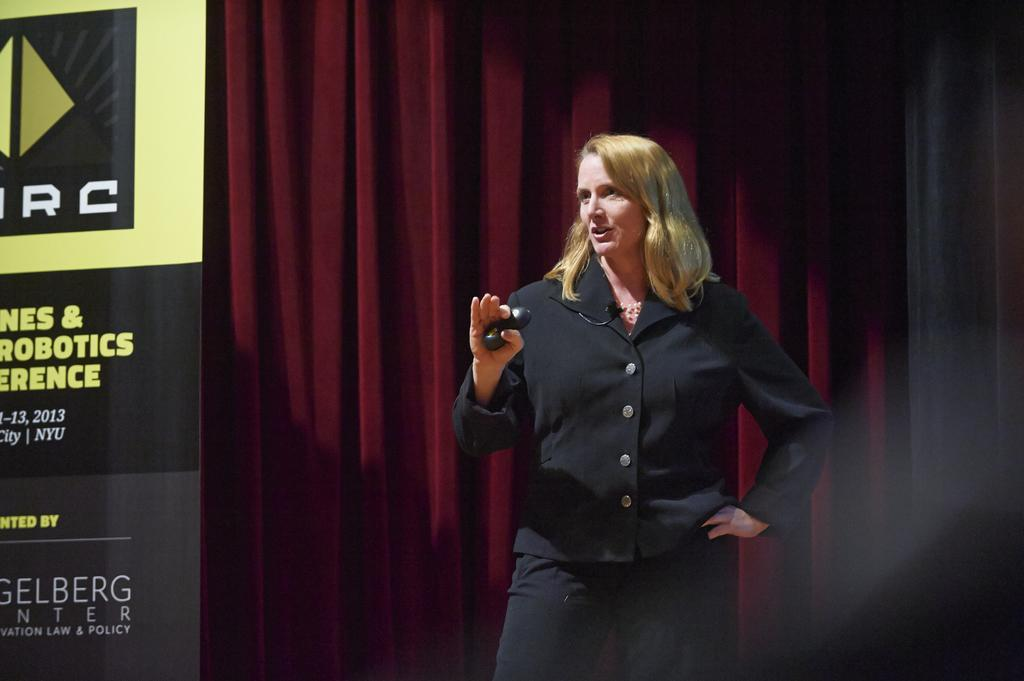What is the lady in the image doing? The lady is standing in the image. What is the lady holding in her hand? The lady is holding something in her hand. How is the lady connected to a sound system? The lady has a mic attached to her dress. What can be seen in the background of the image? There is a curtain in the background of the image. What is on the left side of the image? There is a banner on the left side of the image. What type of dirt can be seen on the canvas in the image? There is no canvas or dirt present in the image. 